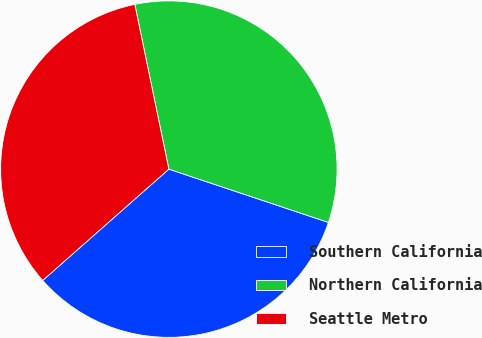<chart> <loc_0><loc_0><loc_500><loc_500><pie_chart><fcel>Southern California<fcel>Northern California<fcel>Seattle Metro<nl><fcel>33.36%<fcel>33.37%<fcel>33.26%<nl></chart> 